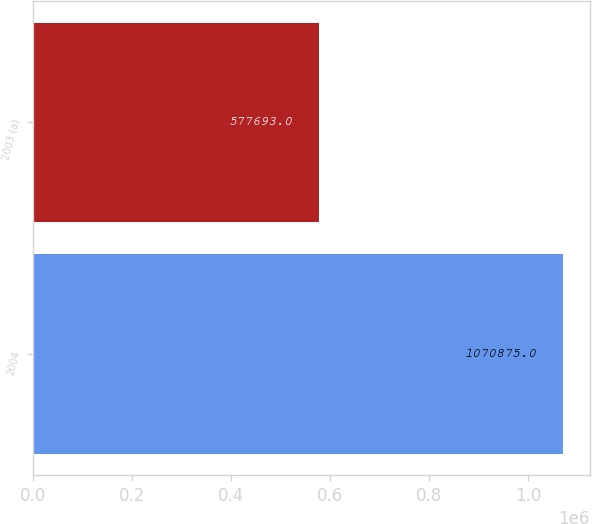Convert chart. <chart><loc_0><loc_0><loc_500><loc_500><bar_chart><fcel>2004<fcel>2003 (a)<nl><fcel>1.07088e+06<fcel>577693<nl></chart> 